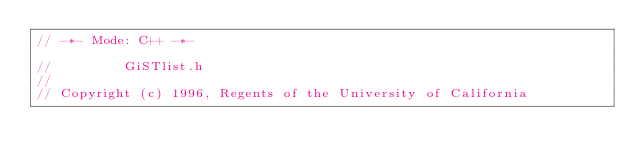Convert code to text. <code><loc_0><loc_0><loc_500><loc_500><_C_>// -*- Mode: C++ -*-

//         GiSTlist.h
//
// Copyright (c) 1996, Regents of the University of California</code> 